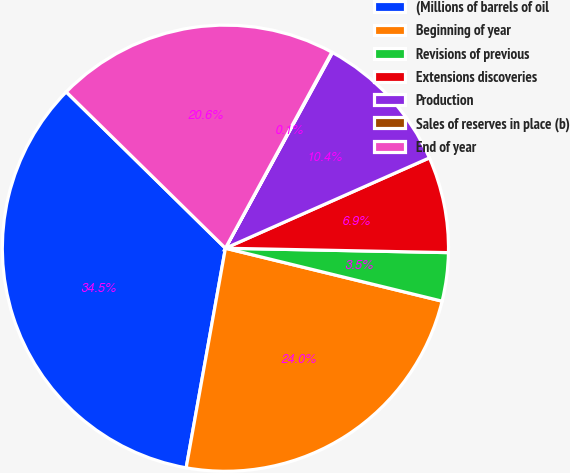Convert chart. <chart><loc_0><loc_0><loc_500><loc_500><pie_chart><fcel>(Millions of barrels of oil<fcel>Beginning of year<fcel>Revisions of previous<fcel>Extensions discoveries<fcel>Production<fcel>Sales of reserves in place (b)<fcel>End of year<nl><fcel>34.54%<fcel>24.0%<fcel>3.5%<fcel>6.95%<fcel>10.4%<fcel>0.05%<fcel>20.56%<nl></chart> 